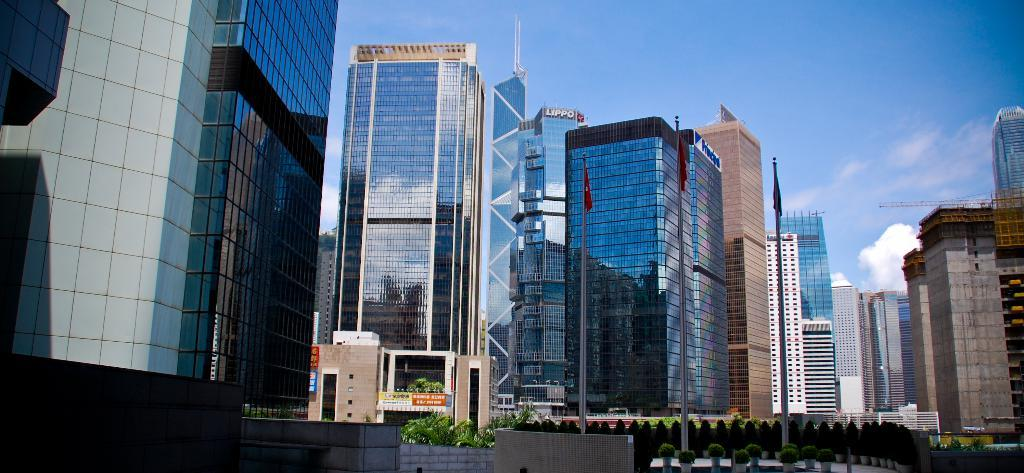What type of structures are present in the image? There are buildings in the image. What can be seen in front of the buildings? There are trees and plants in front of the buildings. What is visible in the background of the image? The sky is visible in the background of the image. Reasoning: Let'g: Let's think step by step in order to produce the conversation. We start by identifying the main subject in the image, which are the buildings. Then, we expand the conversation to include other elements that are also visible, such as the trees, plants, and the sky. Each question is designed to elicit a specific detail about the image that is known from the provided facts. Absurd Question/Answer: What type of bells can be heard ringing in the image? There is no mention of bells or any sounds in the image, so it's not possible to determine what, if any, bells might be heard. What type of street can be seen in the image? There is no street visible in the image; it only shows buildings, trees, plants, and the sky. --- Facts: 1. There is a person sitting on a bench in the image. 2. The person is reading a book. 3. There is a tree behind the bench. 4. The sky is visible in the background of the image. Absurd Topics: parrot, ocean, bicycle Conversation: What is the person in the image doing? The person is sitting on a bench and reading a book. What can be seen behind the bench in the image? There is a tree behind the bench. What is visible in the background of the image? The sky is visible in the background of the image. Reasoning: Let's think step by step in order to produce the conversation. We start by identifying the main subject in the image, which is the person sitting on the bench. Then, we expand the conversation to include other elements that are also visible, such as the book, the tree, and the sky. Each question is designed to elicit a specific detail about the image that is known from the provided facts. Absurd Question/Answer: 